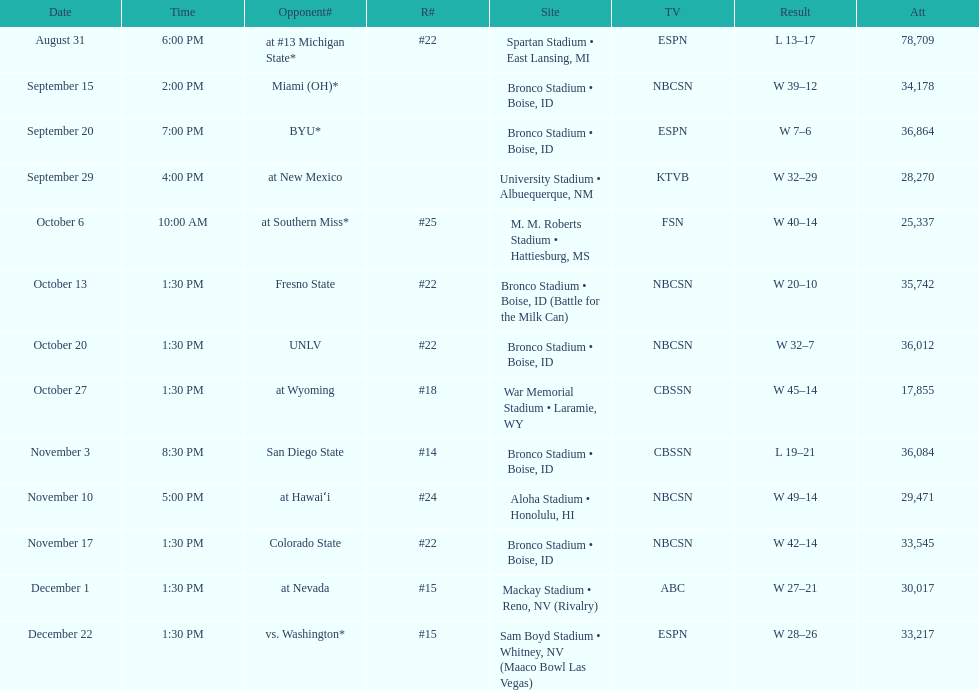Add up the total number of points scored in the last wins for boise state. 146. 